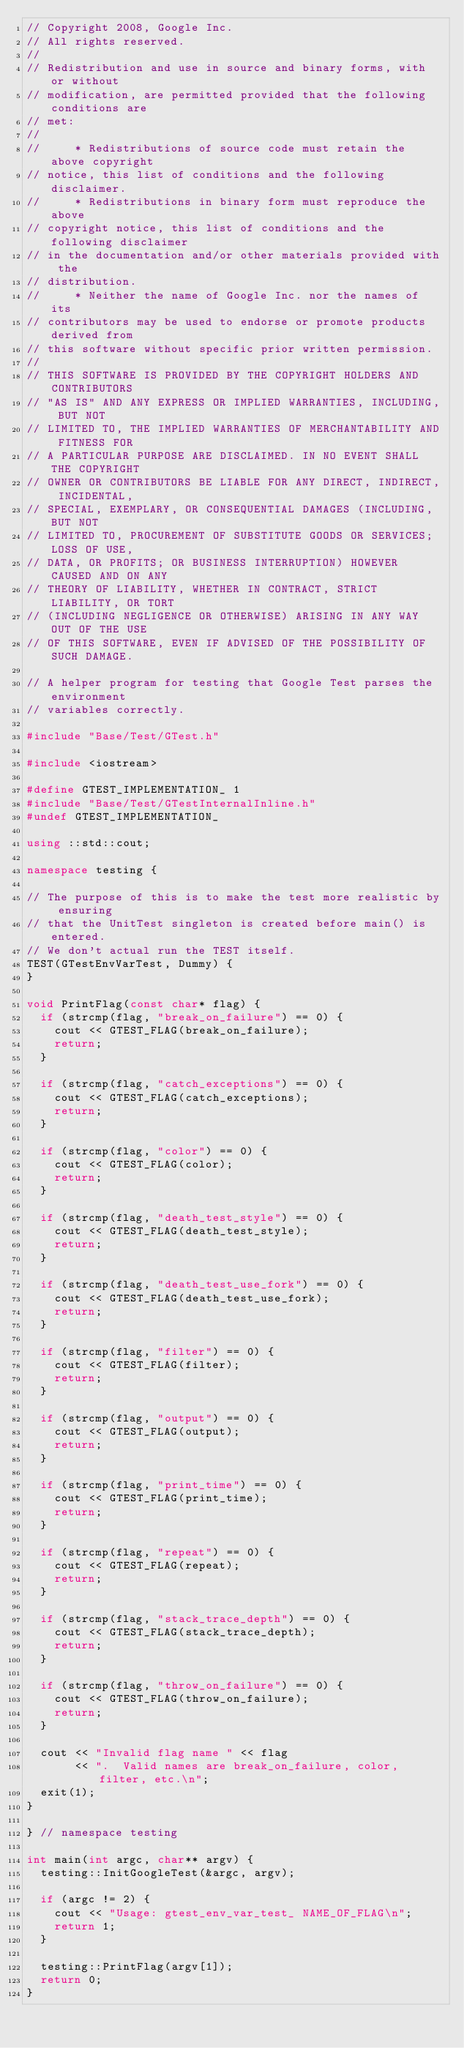<code> <loc_0><loc_0><loc_500><loc_500><_C++_>// Copyright 2008, Google Inc.
// All rights reserved.
//
// Redistribution and use in source and binary forms, with or without
// modification, are permitted provided that the following conditions are
// met:
//
//     * Redistributions of source code must retain the above copyright
// notice, this list of conditions and the following disclaimer.
//     * Redistributions in binary form must reproduce the above
// copyright notice, this list of conditions and the following disclaimer
// in the documentation and/or other materials provided with the
// distribution.
//     * Neither the name of Google Inc. nor the names of its
// contributors may be used to endorse or promote products derived from
// this software without specific prior written permission.
//
// THIS SOFTWARE IS PROVIDED BY THE COPYRIGHT HOLDERS AND CONTRIBUTORS
// "AS IS" AND ANY EXPRESS OR IMPLIED WARRANTIES, INCLUDING, BUT NOT
// LIMITED TO, THE IMPLIED WARRANTIES OF MERCHANTABILITY AND FITNESS FOR
// A PARTICULAR PURPOSE ARE DISCLAIMED. IN NO EVENT SHALL THE COPYRIGHT
// OWNER OR CONTRIBUTORS BE LIABLE FOR ANY DIRECT, INDIRECT, INCIDENTAL,
// SPECIAL, EXEMPLARY, OR CONSEQUENTIAL DAMAGES (INCLUDING, BUT NOT
// LIMITED TO, PROCUREMENT OF SUBSTITUTE GOODS OR SERVICES; LOSS OF USE,
// DATA, OR PROFITS; OR BUSINESS INTERRUPTION) HOWEVER CAUSED AND ON ANY
// THEORY OF LIABILITY, WHETHER IN CONTRACT, STRICT LIABILITY, OR TORT
// (INCLUDING NEGLIGENCE OR OTHERWISE) ARISING IN ANY WAY OUT OF THE USE
// OF THIS SOFTWARE, EVEN IF ADVISED OF THE POSSIBILITY OF SUCH DAMAGE.

// A helper program for testing that Google Test parses the environment
// variables correctly.

#include "Base/Test/GTest.h"

#include <iostream>

#define GTEST_IMPLEMENTATION_ 1
#include "Base/Test/GTestInternalInline.h"
#undef GTEST_IMPLEMENTATION_

using ::std::cout;

namespace testing {

// The purpose of this is to make the test more realistic by ensuring
// that the UnitTest singleton is created before main() is entered.
// We don't actual run the TEST itself.
TEST(GTestEnvVarTest, Dummy) {
}

void PrintFlag(const char* flag) {
  if (strcmp(flag, "break_on_failure") == 0) {
    cout << GTEST_FLAG(break_on_failure);
    return;
  }

  if (strcmp(flag, "catch_exceptions") == 0) {
    cout << GTEST_FLAG(catch_exceptions);
    return;
  }

  if (strcmp(flag, "color") == 0) {
    cout << GTEST_FLAG(color);
    return;
  }

  if (strcmp(flag, "death_test_style") == 0) {
    cout << GTEST_FLAG(death_test_style);
    return;
  }

  if (strcmp(flag, "death_test_use_fork") == 0) {
    cout << GTEST_FLAG(death_test_use_fork);
    return;
  }

  if (strcmp(flag, "filter") == 0) {
    cout << GTEST_FLAG(filter);
    return;
  }

  if (strcmp(flag, "output") == 0) {
    cout << GTEST_FLAG(output);
    return;
  }

  if (strcmp(flag, "print_time") == 0) {
    cout << GTEST_FLAG(print_time);
    return;
  }

  if (strcmp(flag, "repeat") == 0) {
    cout << GTEST_FLAG(repeat);
    return;
  }

  if (strcmp(flag, "stack_trace_depth") == 0) {
    cout << GTEST_FLAG(stack_trace_depth);
    return;
  }

  if (strcmp(flag, "throw_on_failure") == 0) {
    cout << GTEST_FLAG(throw_on_failure);
    return;
  }

  cout << "Invalid flag name " << flag
       << ".  Valid names are break_on_failure, color, filter, etc.\n";
  exit(1);
}

} // namespace testing

int main(int argc, char** argv) {
  testing::InitGoogleTest(&argc, argv);

  if (argc != 2) {
    cout << "Usage: gtest_env_var_test_ NAME_OF_FLAG\n";
    return 1;
  }

  testing::PrintFlag(argv[1]);
  return 0;
}
</code> 